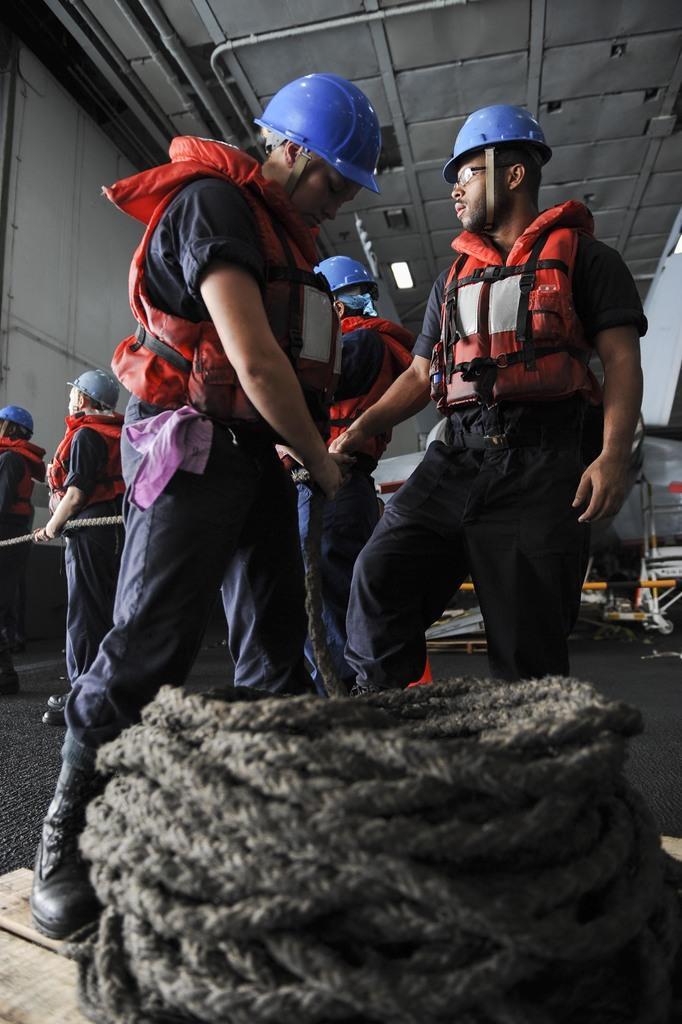Describe this image in one or two sentences. A group of men are holding the rope, they wore red color life jackets, blue color helmets and grey color trousers. This is the rope in this image. 